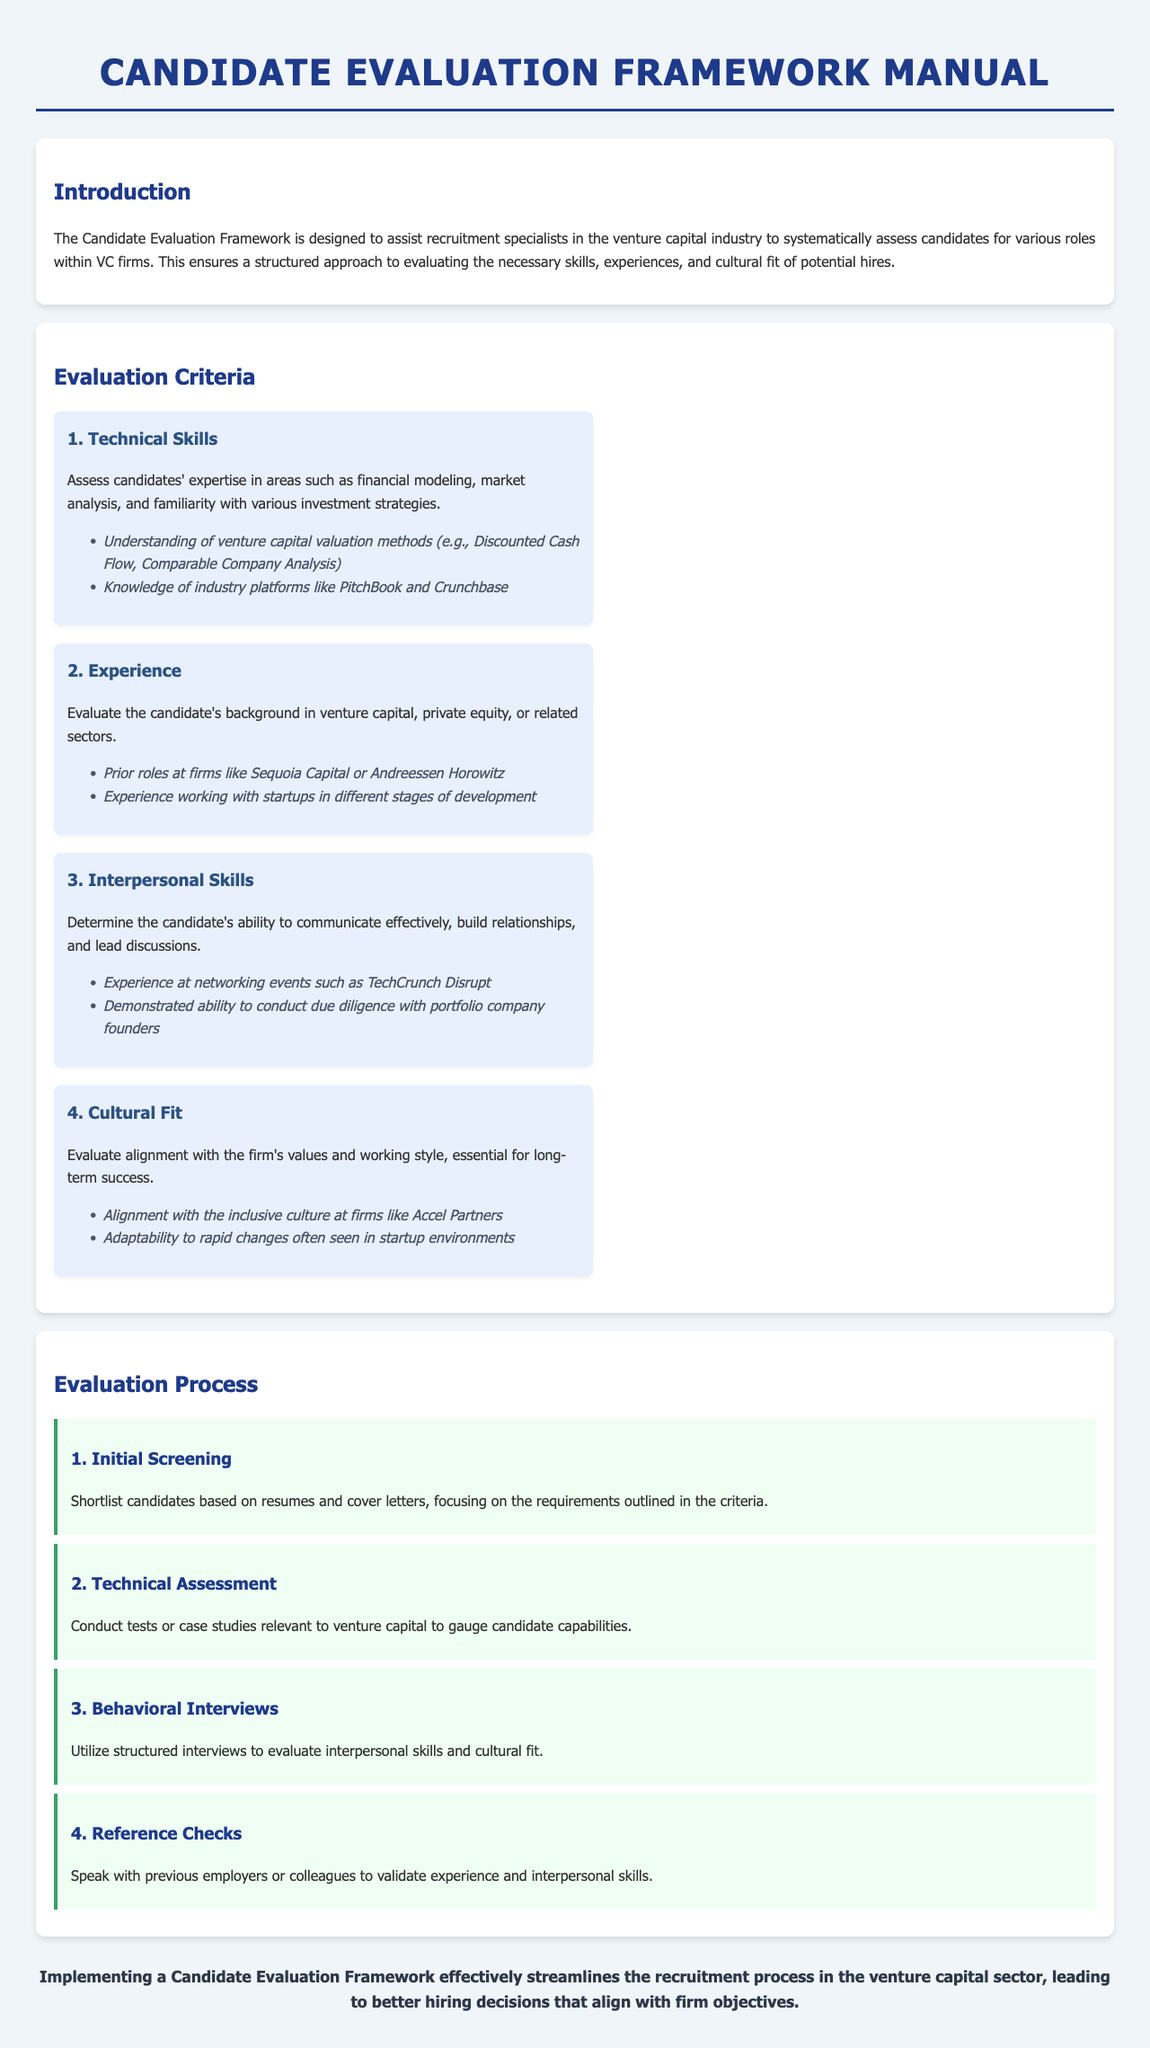What is the purpose of the Candidate Evaluation Framework? The purpose is to assist recruitment specialists in systematically assessing candidates for various roles within VC firms.
Answer: To assist recruitment specialists What are the four evaluation criteria? The four evaluation criteria are Technical Skills, Experience, Interpersonal Skills, and Cultural Fit.
Answer: Technical Skills, Experience, Interpersonal Skills, Cultural Fit Which technical skill involves understanding valuation methods? The skill involves understanding venture capital valuation methods.
Answer: Venture capital valuation methods What is the first step in the evaluation process? The first step is Initial Screening.
Answer: Initial Screening Which firm is mentioned in relation to cultural fit? Accel Partners is mentioned in relation to cultural fit.
Answer: Accel Partners What type of interviews is used to assess interpersonal skills? Structured interviews are used to assess interpersonal skills.
Answer: Structured interviews How many steps are in the evaluation process? There are four steps in the evaluation process.
Answer: Four steps Which tool is associated with technical skills assessment? Industry platforms like PitchBook and Crunchbase are associated with technical skills.
Answer: PitchBook and Crunchbase What does the conclusion emphasize? The conclusion emphasizes streamlining the recruitment process for better hiring decisions.
Answer: Streamlining the recruitment process 